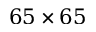Convert formula to latex. <formula><loc_0><loc_0><loc_500><loc_500>6 5 \times 6 5</formula> 